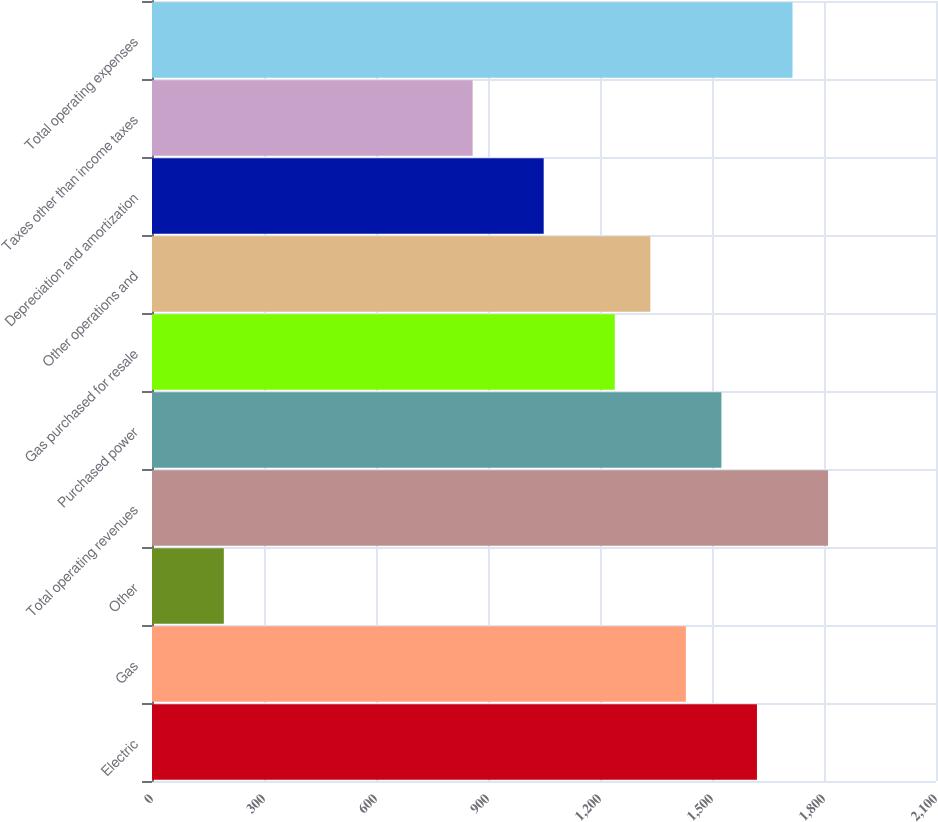Convert chart. <chart><loc_0><loc_0><loc_500><loc_500><bar_chart><fcel>Electric<fcel>Gas<fcel>Other<fcel>Total operating revenues<fcel>Purchased power<fcel>Gas purchased for resale<fcel>Other operations and<fcel>Depreciation and amortization<fcel>Taxes other than income taxes<fcel>Total operating expenses<nl><fcel>1620.4<fcel>1430<fcel>192.4<fcel>1810.8<fcel>1525.2<fcel>1239.6<fcel>1334.8<fcel>1049.2<fcel>858.8<fcel>1715.6<nl></chart> 